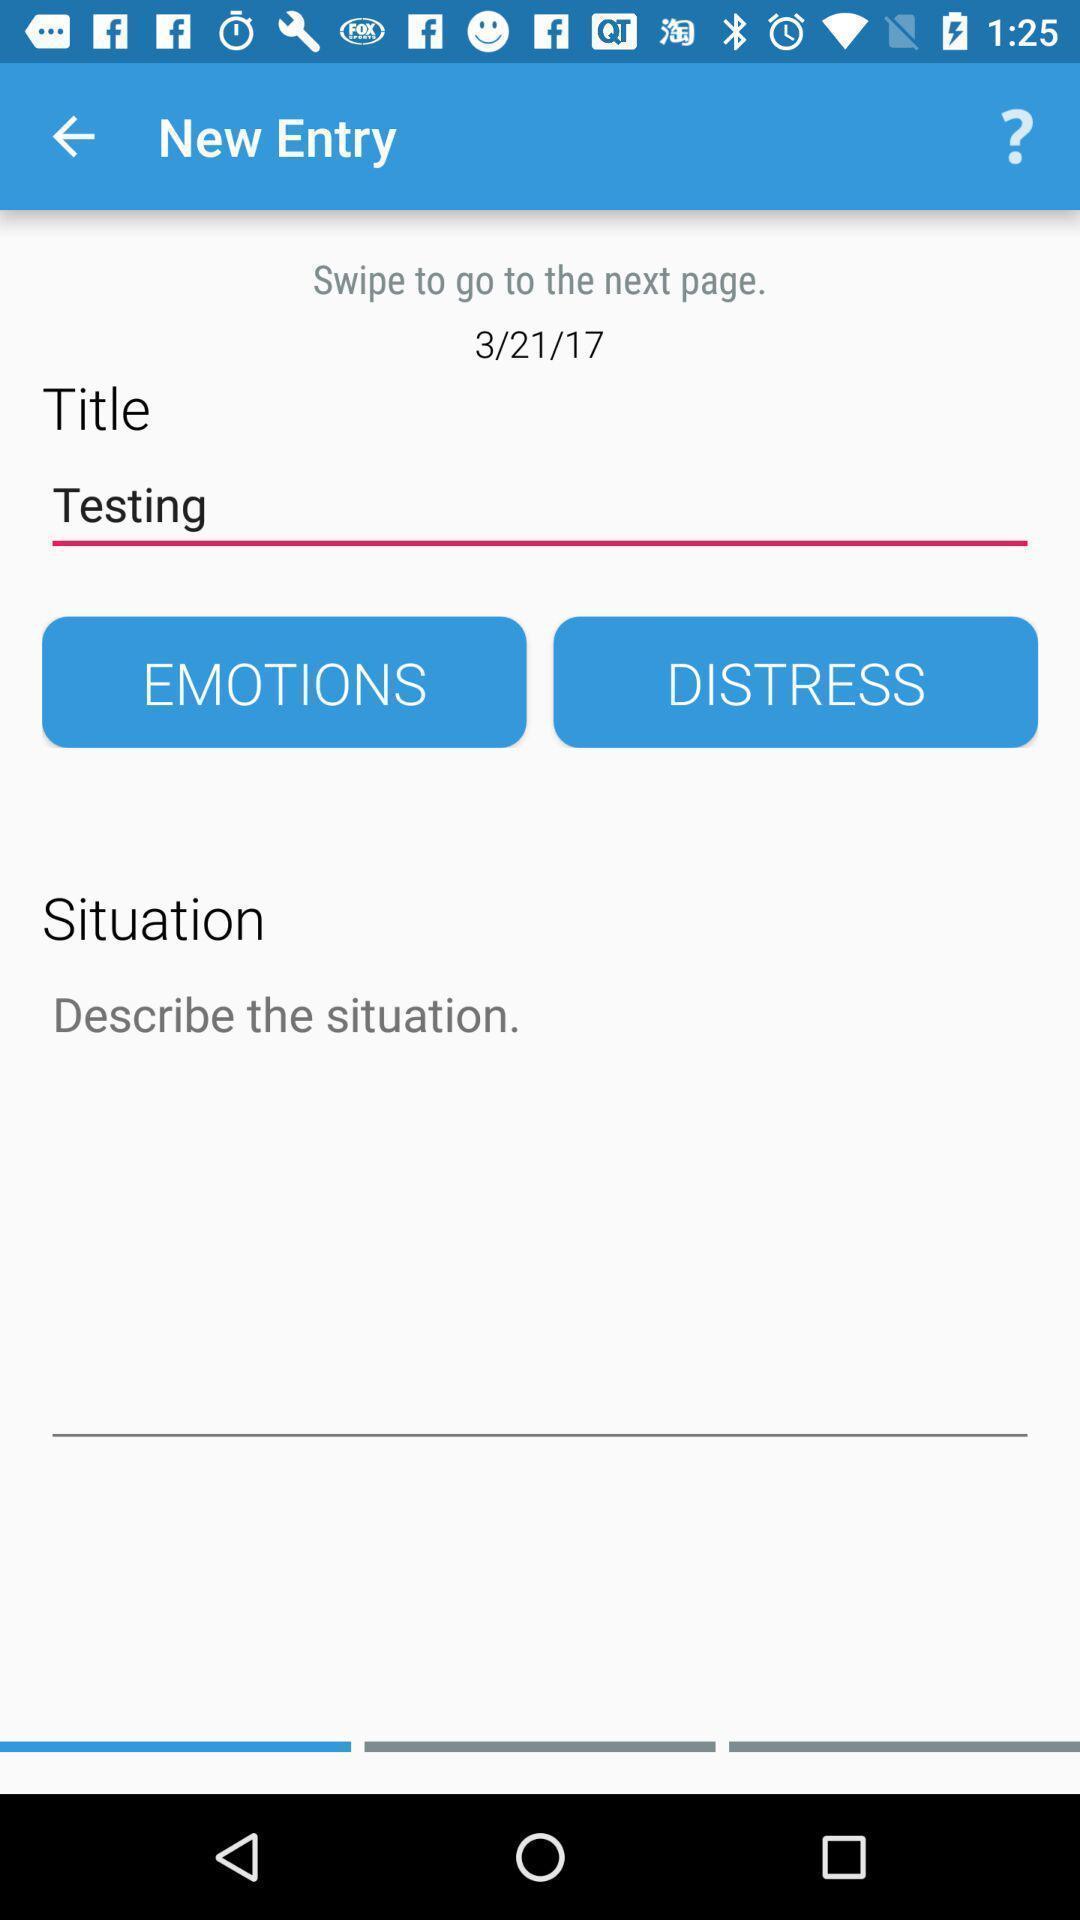Summarize the main components in this picture. Situation description recording page for a self-help mental help app. 